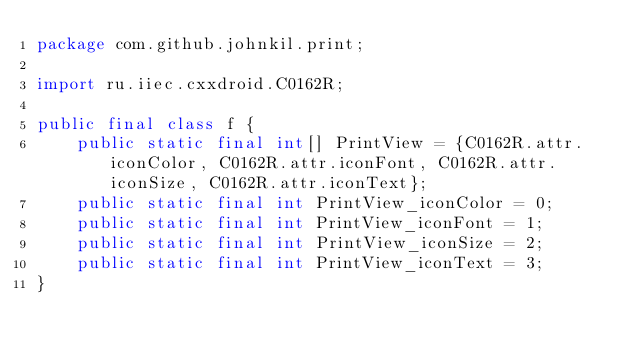Convert code to text. <code><loc_0><loc_0><loc_500><loc_500><_Java_>package com.github.johnkil.print;

import ru.iiec.cxxdroid.C0162R;

public final class f {
    public static final int[] PrintView = {C0162R.attr.iconColor, C0162R.attr.iconFont, C0162R.attr.iconSize, C0162R.attr.iconText};
    public static final int PrintView_iconColor = 0;
    public static final int PrintView_iconFont = 1;
    public static final int PrintView_iconSize = 2;
    public static final int PrintView_iconText = 3;
}
</code> 